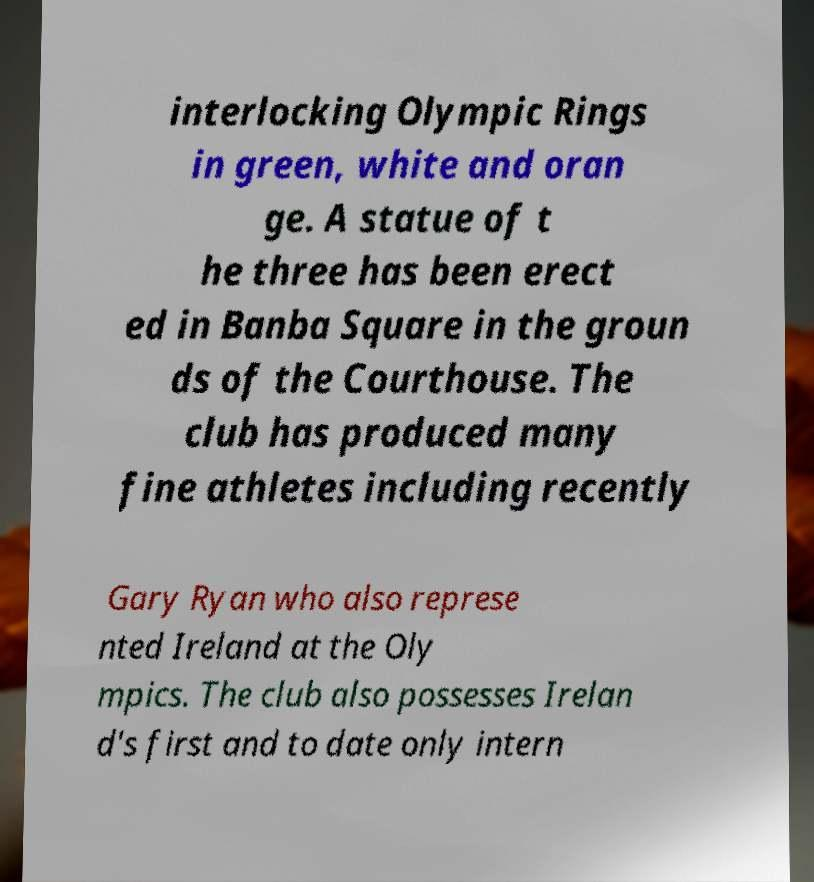I need the written content from this picture converted into text. Can you do that? interlocking Olympic Rings in green, white and oran ge. A statue of t he three has been erect ed in Banba Square in the groun ds of the Courthouse. The club has produced many fine athletes including recently Gary Ryan who also represe nted Ireland at the Oly mpics. The club also possesses Irelan d's first and to date only intern 